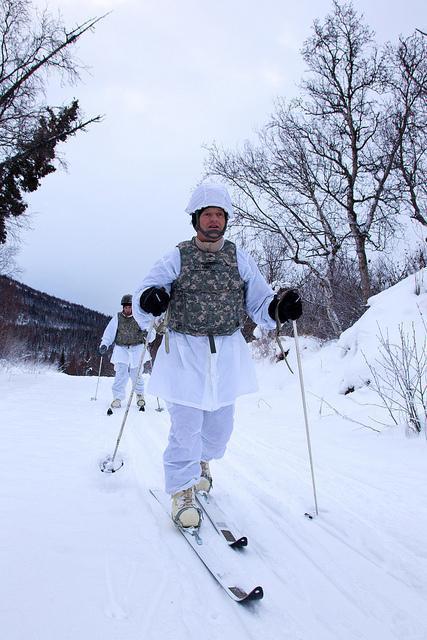How many people are skiing?
Give a very brief answer. 2. How many people are there?
Give a very brief answer. 2. 